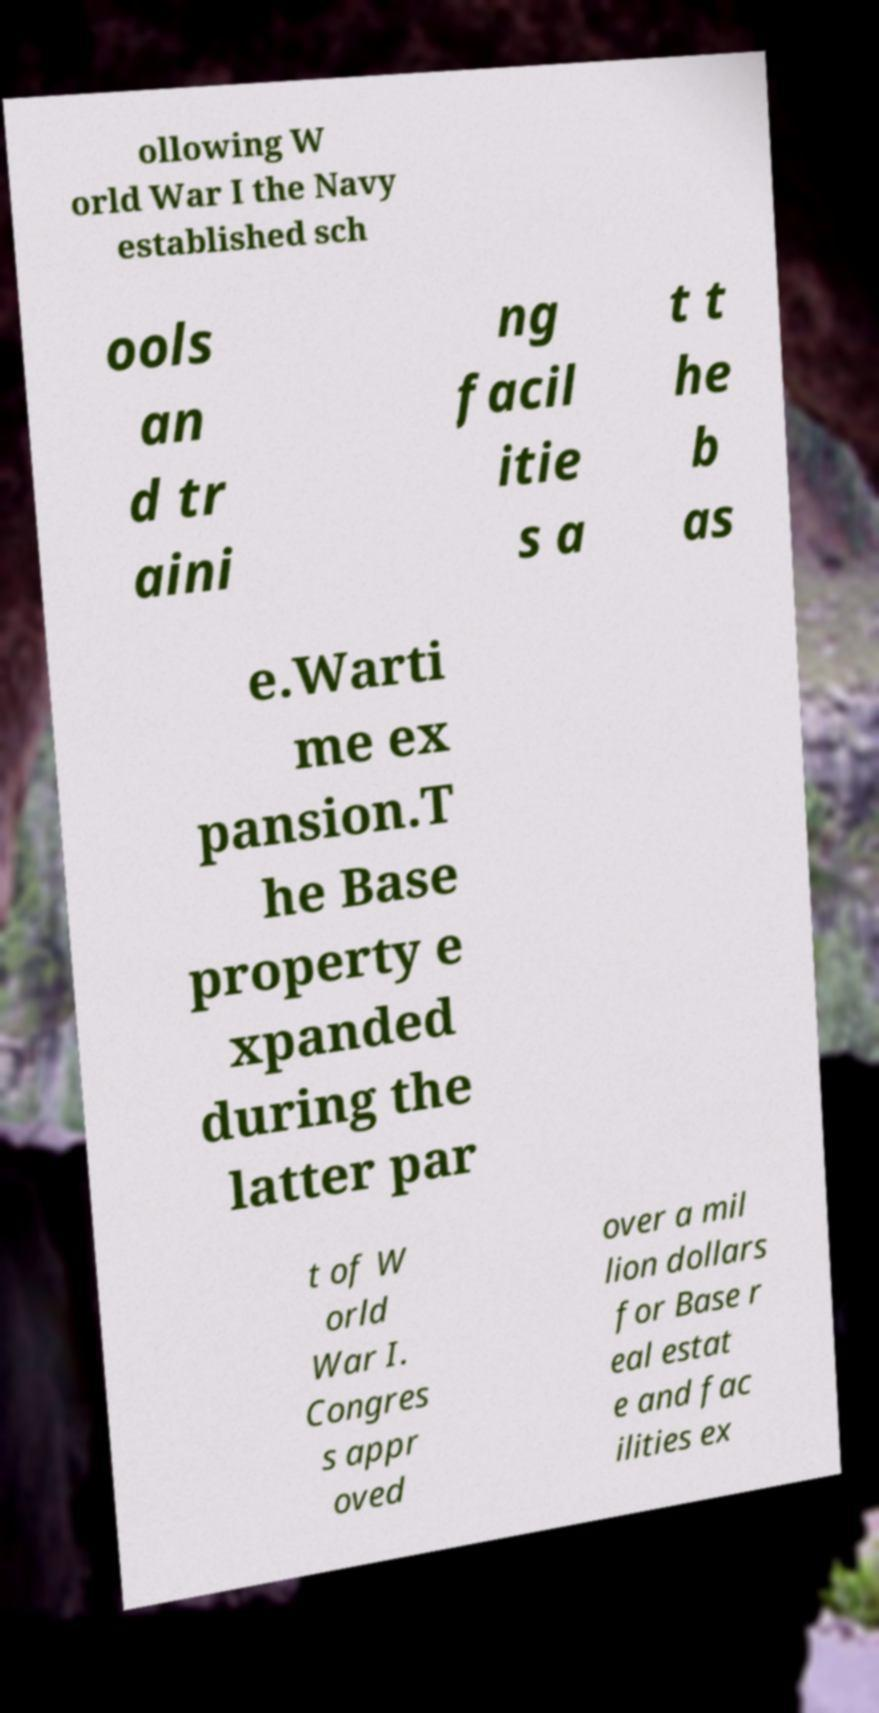Please read and relay the text visible in this image. What does it say? ollowing W orld War I the Navy established sch ools an d tr aini ng facil itie s a t t he b as e.Warti me ex pansion.T he Base property e xpanded during the latter par t of W orld War I. Congres s appr oved over a mil lion dollars for Base r eal estat e and fac ilities ex 